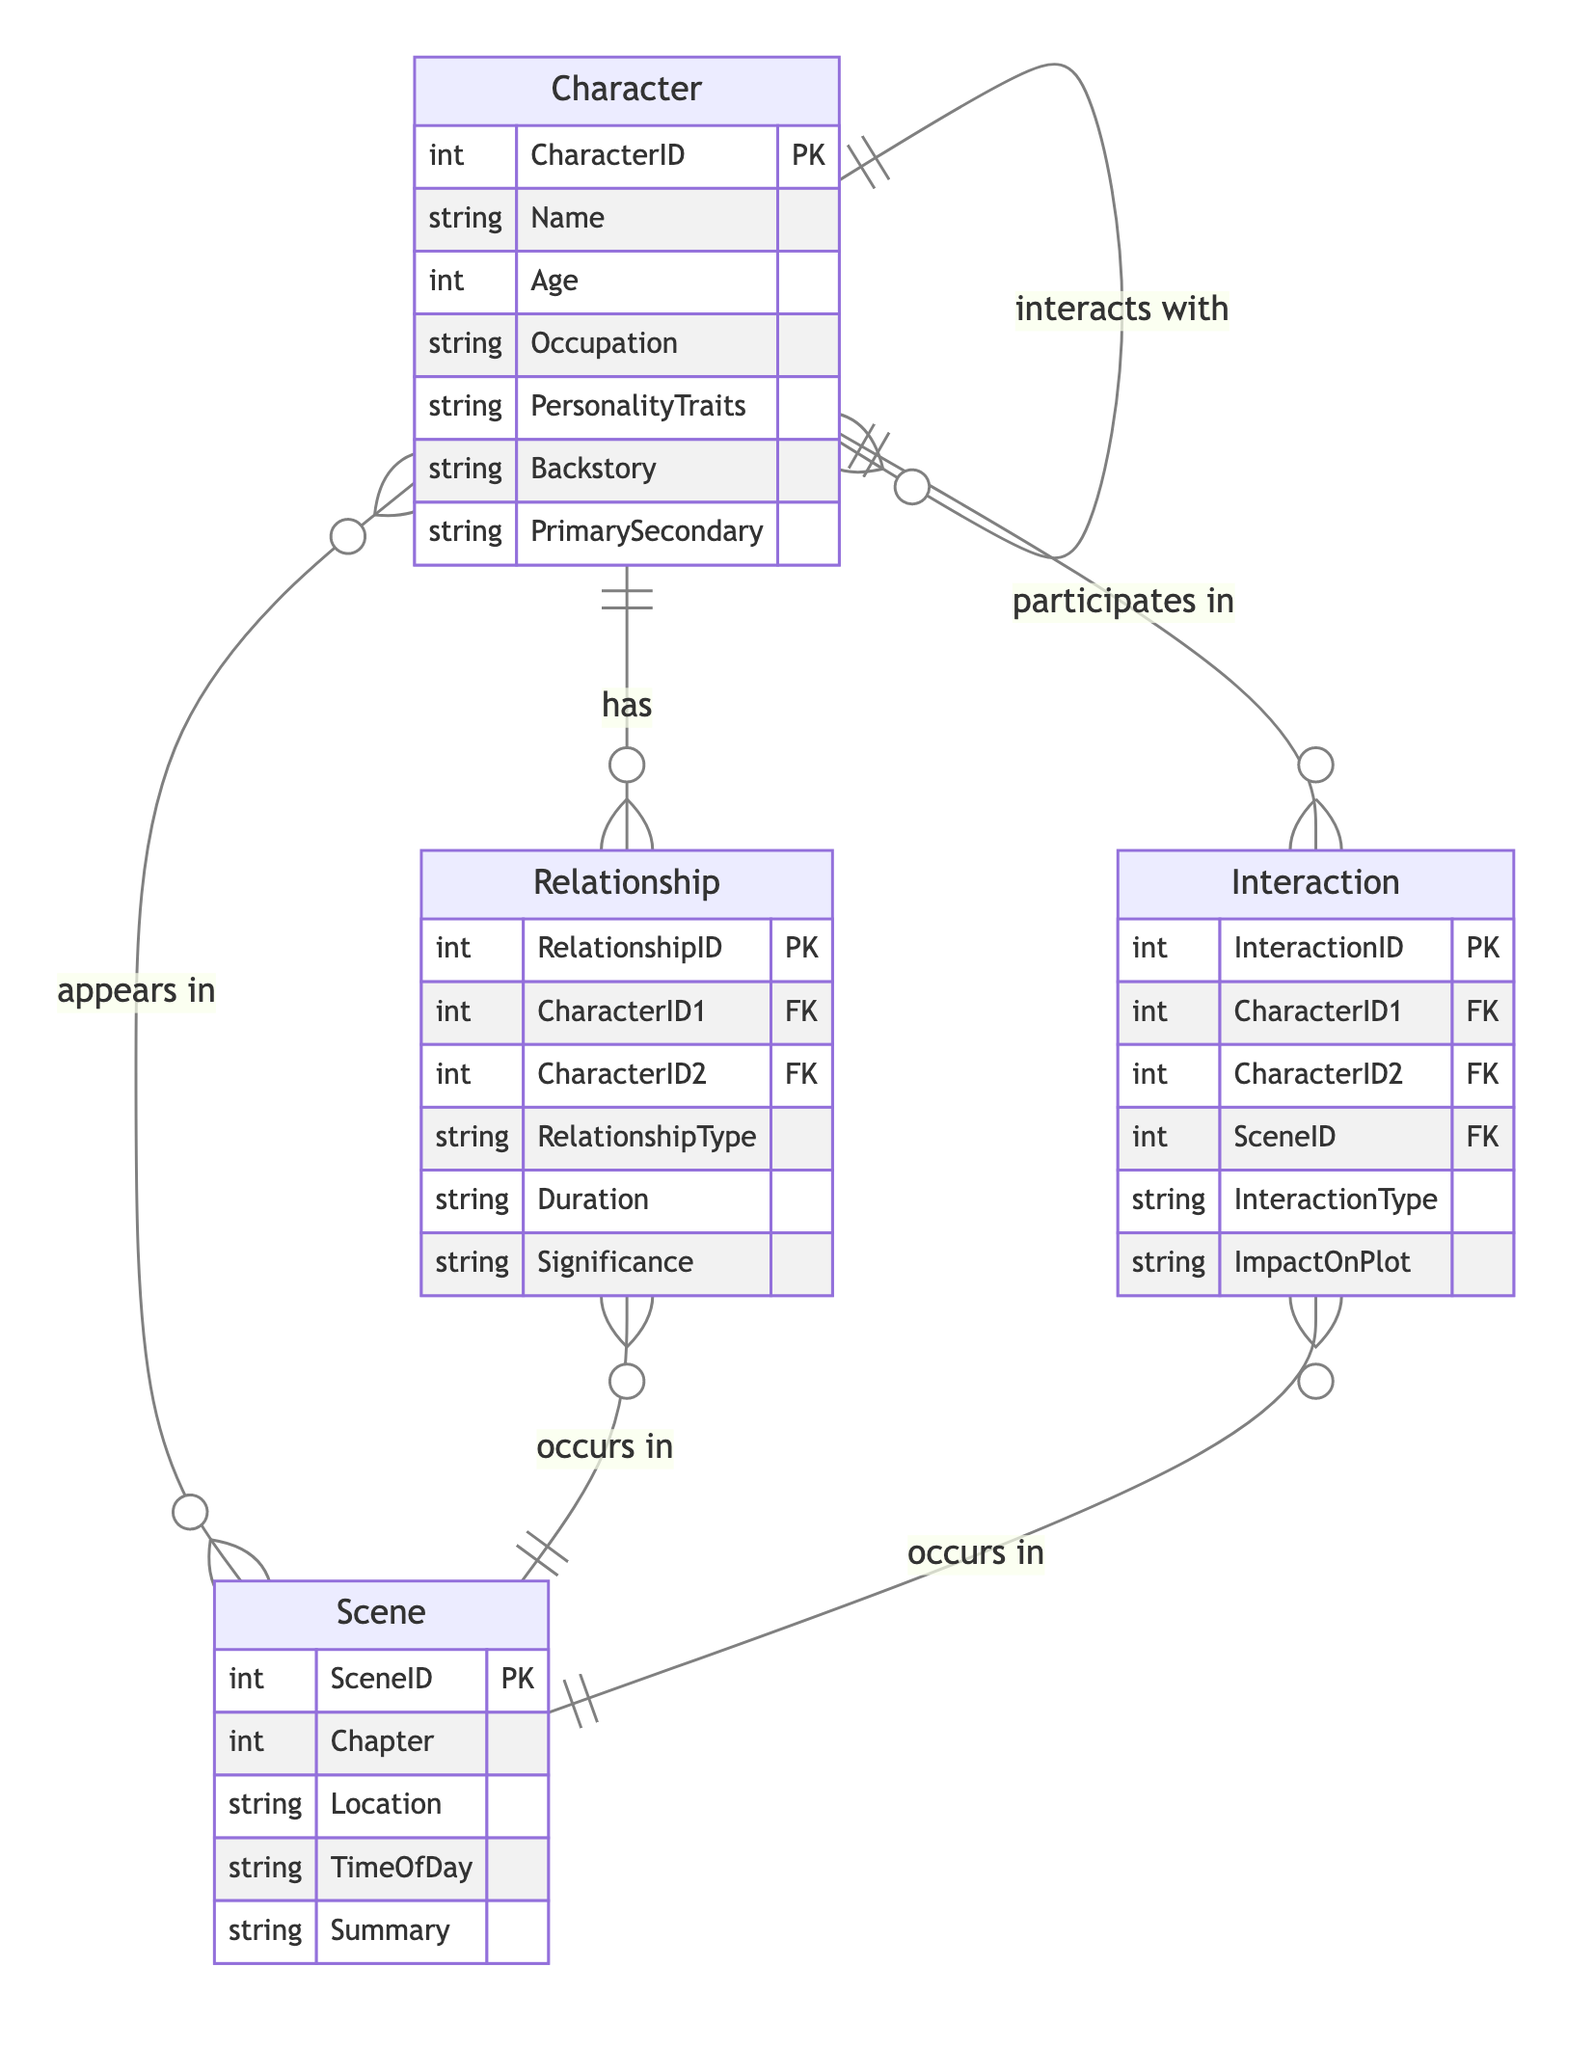How many entities are in the diagram? The diagram features four distinct entities: Character, Relationship, Interaction, and Scene. This can be determined by counting the number of entity listings in the diagram.
Answer: 4 What is the relationship type between Character and Scene? The relationship type between Character and Scene is "appears in." This is inferred from the "appears in" label connecting these two entities in the diagram.
Answer: appears in What attributes are associated with the Interaction entity? The attributes associated with the Interaction entity are InteractionID, CharacterID1, CharacterID2, SceneID, InteractionType, and ImpactOnPlot. This is found by listing all attributes under the Interaction entity in the diagram.
Answer: InteractionID, CharacterID1, CharacterID2, SceneID, InteractionType, ImpactOnPlot What is the significance of the Relationship entity? The attribute "Significance" is part of the Relationship entity, which indicates how important the relationship between the characters is within the story. This can be confirmed by examining the attributes listed under the Relationship entity.
Answer: Significance Which entity contains the attribute "Backstory"? The attribute "Backstory" is part of the Character entity, as listed among its various attributes in the diagram.
Answer: Character What relationship does an Interaction have with a Scene? An Interaction occurs in a Scene, indicated by the labeling "occurs in" connecting the Interaction and Scene entities. This reflects the nature of how interactions are linked to specific scenes in the narrative.
Answer: occurs in 